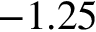<formula> <loc_0><loc_0><loc_500><loc_500>- 1 . 2 5</formula> 